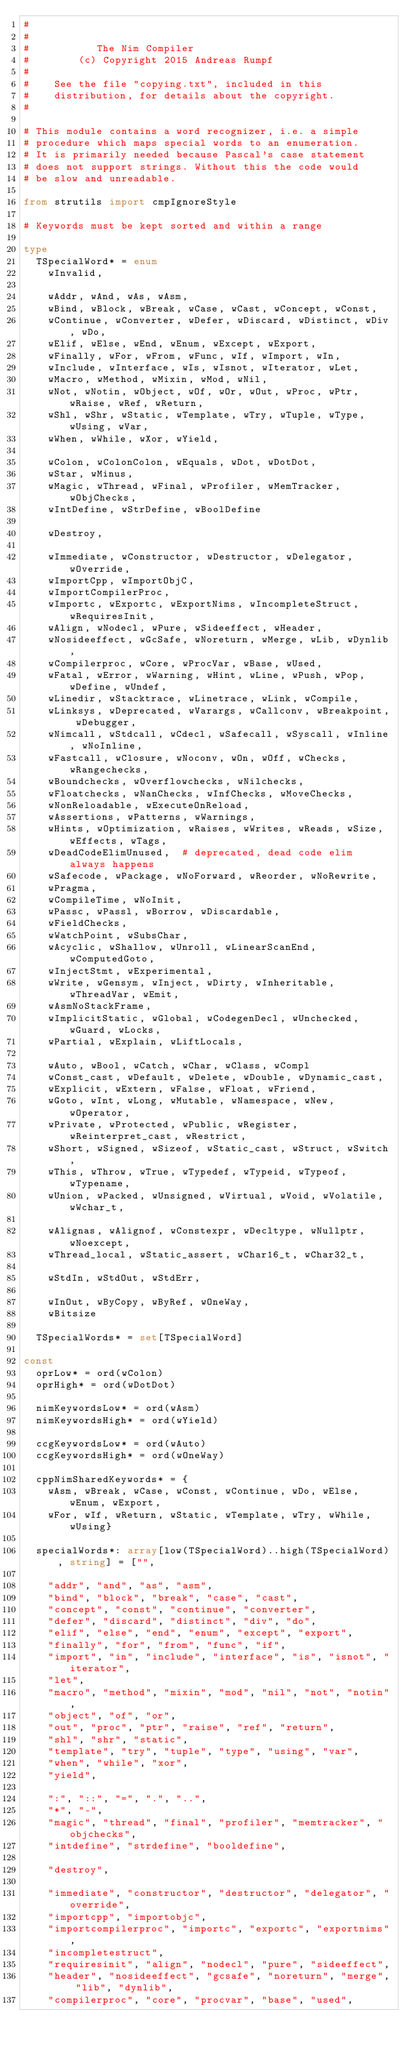<code> <loc_0><loc_0><loc_500><loc_500><_Nim_>#
#
#           The Nim Compiler
#        (c) Copyright 2015 Andreas Rumpf
#
#    See the file "copying.txt", included in this
#    distribution, for details about the copyright.
#

# This module contains a word recognizer, i.e. a simple
# procedure which maps special words to an enumeration.
# It is primarily needed because Pascal's case statement
# does not support strings. Without this the code would
# be slow and unreadable.

from strutils import cmpIgnoreStyle

# Keywords must be kept sorted and within a range

type
  TSpecialWord* = enum
    wInvalid,

    wAddr, wAnd, wAs, wAsm,
    wBind, wBlock, wBreak, wCase, wCast, wConcept, wConst,
    wContinue, wConverter, wDefer, wDiscard, wDistinct, wDiv, wDo,
    wElif, wElse, wEnd, wEnum, wExcept, wExport,
    wFinally, wFor, wFrom, wFunc, wIf, wImport, wIn,
    wInclude, wInterface, wIs, wIsnot, wIterator, wLet,
    wMacro, wMethod, wMixin, wMod, wNil,
    wNot, wNotin, wObject, wOf, wOr, wOut, wProc, wPtr, wRaise, wRef, wReturn,
    wShl, wShr, wStatic, wTemplate, wTry, wTuple, wType, wUsing, wVar,
    wWhen, wWhile, wXor, wYield,

    wColon, wColonColon, wEquals, wDot, wDotDot,
    wStar, wMinus,
    wMagic, wThread, wFinal, wProfiler, wMemTracker, wObjChecks,
    wIntDefine, wStrDefine, wBoolDefine

    wDestroy,

    wImmediate, wConstructor, wDestructor, wDelegator, wOverride,
    wImportCpp, wImportObjC,
    wImportCompilerProc,
    wImportc, wExportc, wExportNims, wIncompleteStruct, wRequiresInit,
    wAlign, wNodecl, wPure, wSideeffect, wHeader,
    wNosideeffect, wGcSafe, wNoreturn, wMerge, wLib, wDynlib,
    wCompilerproc, wCore, wProcVar, wBase, wUsed,
    wFatal, wError, wWarning, wHint, wLine, wPush, wPop, wDefine, wUndef,
    wLinedir, wStacktrace, wLinetrace, wLink, wCompile,
    wLinksys, wDeprecated, wVarargs, wCallconv, wBreakpoint, wDebugger,
    wNimcall, wStdcall, wCdecl, wSafecall, wSyscall, wInline, wNoInline,
    wFastcall, wClosure, wNoconv, wOn, wOff, wChecks, wRangechecks,
    wBoundchecks, wOverflowchecks, wNilchecks,
    wFloatchecks, wNanChecks, wInfChecks, wMoveChecks,
    wNonReloadable, wExecuteOnReload,
    wAssertions, wPatterns, wWarnings,
    wHints, wOptimization, wRaises, wWrites, wReads, wSize, wEffects, wTags,
    wDeadCodeElimUnused,  # deprecated, dead code elim always happens
    wSafecode, wPackage, wNoForward, wReorder, wNoRewrite,
    wPragma,
    wCompileTime, wNoInit,
    wPassc, wPassl, wBorrow, wDiscardable,
    wFieldChecks,
    wWatchPoint, wSubsChar,
    wAcyclic, wShallow, wUnroll, wLinearScanEnd, wComputedGoto,
    wInjectStmt, wExperimental,
    wWrite, wGensym, wInject, wDirty, wInheritable, wThreadVar, wEmit,
    wAsmNoStackFrame,
    wImplicitStatic, wGlobal, wCodegenDecl, wUnchecked, wGuard, wLocks,
    wPartial, wExplain, wLiftLocals,

    wAuto, wBool, wCatch, wChar, wClass, wCompl
    wConst_cast, wDefault, wDelete, wDouble, wDynamic_cast,
    wExplicit, wExtern, wFalse, wFloat, wFriend,
    wGoto, wInt, wLong, wMutable, wNamespace, wNew, wOperator,
    wPrivate, wProtected, wPublic, wRegister, wReinterpret_cast, wRestrict,
    wShort, wSigned, wSizeof, wStatic_cast, wStruct, wSwitch,
    wThis, wThrow, wTrue, wTypedef, wTypeid, wTypeof, wTypename,
    wUnion, wPacked, wUnsigned, wVirtual, wVoid, wVolatile, wWchar_t,

    wAlignas, wAlignof, wConstexpr, wDecltype, wNullptr, wNoexcept,
    wThread_local, wStatic_assert, wChar16_t, wChar32_t,

    wStdIn, wStdOut, wStdErr,

    wInOut, wByCopy, wByRef, wOneWay,
    wBitsize

  TSpecialWords* = set[TSpecialWord]

const
  oprLow* = ord(wColon)
  oprHigh* = ord(wDotDot)

  nimKeywordsLow* = ord(wAsm)
  nimKeywordsHigh* = ord(wYield)

  ccgKeywordsLow* = ord(wAuto)
  ccgKeywordsHigh* = ord(wOneWay)

  cppNimSharedKeywords* = {
    wAsm, wBreak, wCase, wConst, wContinue, wDo, wElse, wEnum, wExport,
    wFor, wIf, wReturn, wStatic, wTemplate, wTry, wWhile, wUsing}

  specialWords*: array[low(TSpecialWord)..high(TSpecialWord), string] = ["",

    "addr", "and", "as", "asm",
    "bind", "block", "break", "case", "cast",
    "concept", "const", "continue", "converter",
    "defer", "discard", "distinct", "div", "do",
    "elif", "else", "end", "enum", "except", "export",
    "finally", "for", "from", "func", "if",
    "import", "in", "include", "interface", "is", "isnot", "iterator",
    "let",
    "macro", "method", "mixin", "mod", "nil", "not", "notin",
    "object", "of", "or",
    "out", "proc", "ptr", "raise", "ref", "return",
    "shl", "shr", "static",
    "template", "try", "tuple", "type", "using", "var",
    "when", "while", "xor",
    "yield",

    ":", "::", "=", ".", "..",
    "*", "-",
    "magic", "thread", "final", "profiler", "memtracker", "objchecks",
    "intdefine", "strdefine", "booldefine",

    "destroy",

    "immediate", "constructor", "destructor", "delegator", "override",
    "importcpp", "importobjc",
    "importcompilerproc", "importc", "exportc", "exportnims",
    "incompletestruct",
    "requiresinit", "align", "nodecl", "pure", "sideeffect",
    "header", "nosideeffect", "gcsafe", "noreturn", "merge", "lib", "dynlib",
    "compilerproc", "core", "procvar", "base", "used",</code> 